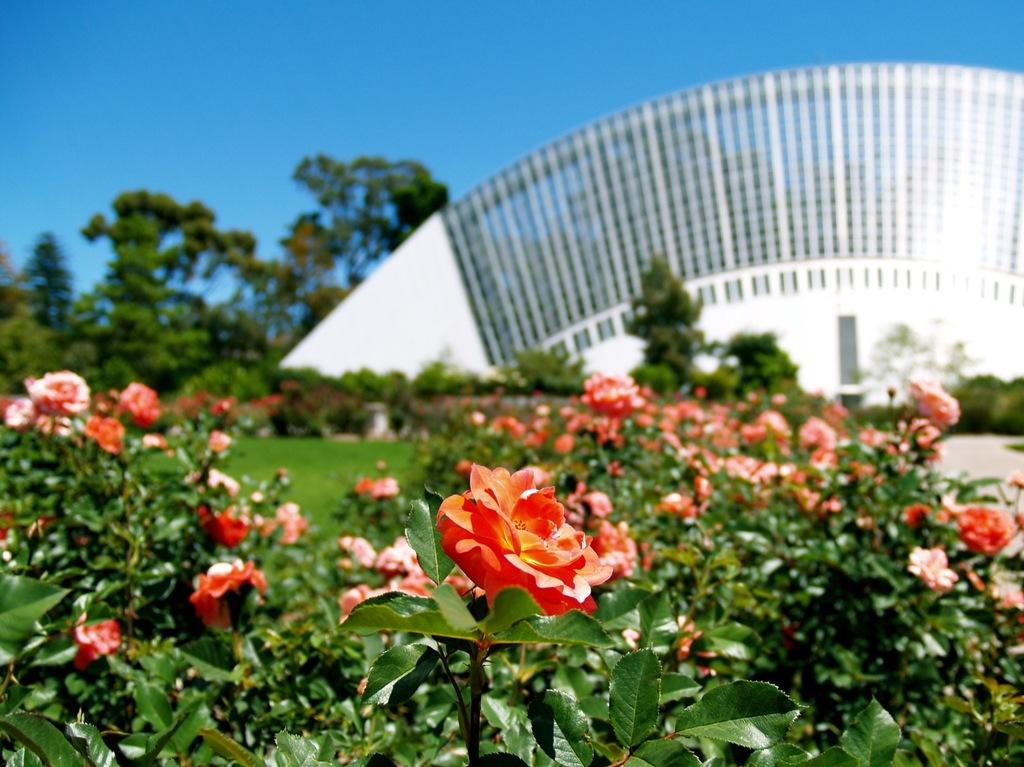What types of plants are present in the image? There are many flowering plants in the image. What can be seen in the background of the image? There is grass, trees, and the sky visible in the background of the image. What is the color of the arch in the background of the image? The arch in the background of the image is white. What is the opinion of the church about the flowering plants in the image? There is no church present in the image, and therefore no opinion can be attributed to it. 